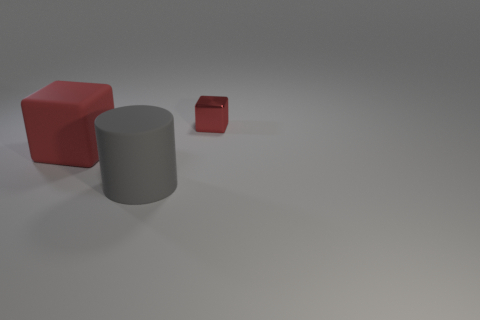Subtract all red cubes. How many were subtracted if there are1red cubes left? 1 Add 3 big objects. How many objects exist? 6 Subtract all cylinders. How many objects are left? 2 Subtract 1 blocks. How many blocks are left? 1 Subtract all purple cubes. Subtract all blue balls. How many cubes are left? 2 Subtract all small green cylinders. Subtract all large objects. How many objects are left? 1 Add 2 gray cylinders. How many gray cylinders are left? 3 Add 3 tiny green rubber things. How many tiny green rubber things exist? 3 Subtract 0 blue cylinders. How many objects are left? 3 